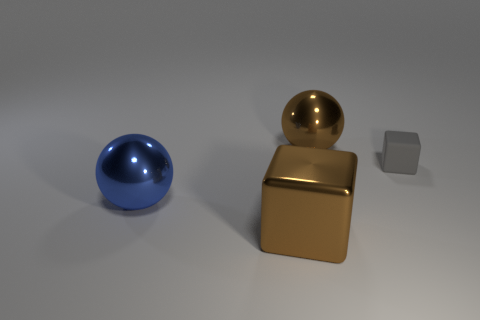Add 1 red rubber blocks. How many objects exist? 5 Subtract all big blue balls. Subtract all brown objects. How many objects are left? 1 Add 3 brown shiny balls. How many brown shiny balls are left? 4 Add 1 cyan blocks. How many cyan blocks exist? 1 Subtract 0 cyan cubes. How many objects are left? 4 